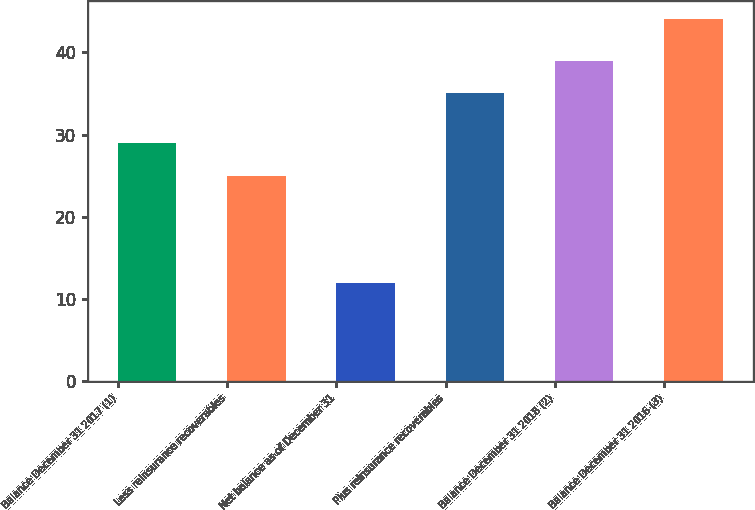Convert chart. <chart><loc_0><loc_0><loc_500><loc_500><bar_chart><fcel>Balance December 31 2017 (1)<fcel>Less reinsurance recoverables<fcel>Net balance as of December 31<fcel>Plus reinsurance recoverables<fcel>Balance December 31 2018 (2)<fcel>Balance December 31 2016 (3)<nl><fcel>29<fcel>25<fcel>12<fcel>35<fcel>39<fcel>44<nl></chart> 